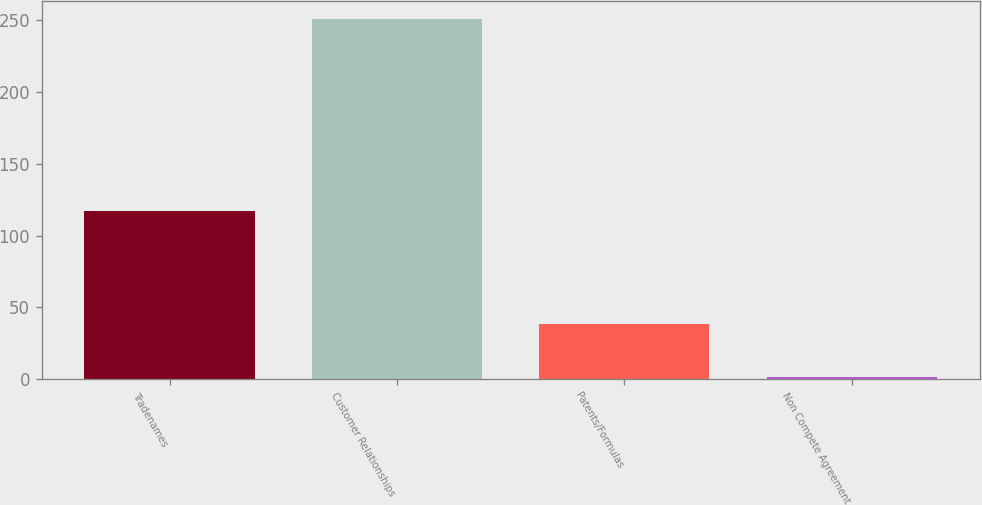Convert chart to OTSL. <chart><loc_0><loc_0><loc_500><loc_500><bar_chart><fcel>Tradenames<fcel>Customer Relationships<fcel>Patents/Formulas<fcel>Non Compete Agreement<nl><fcel>117.1<fcel>250.5<fcel>38.5<fcel>1.4<nl></chart> 